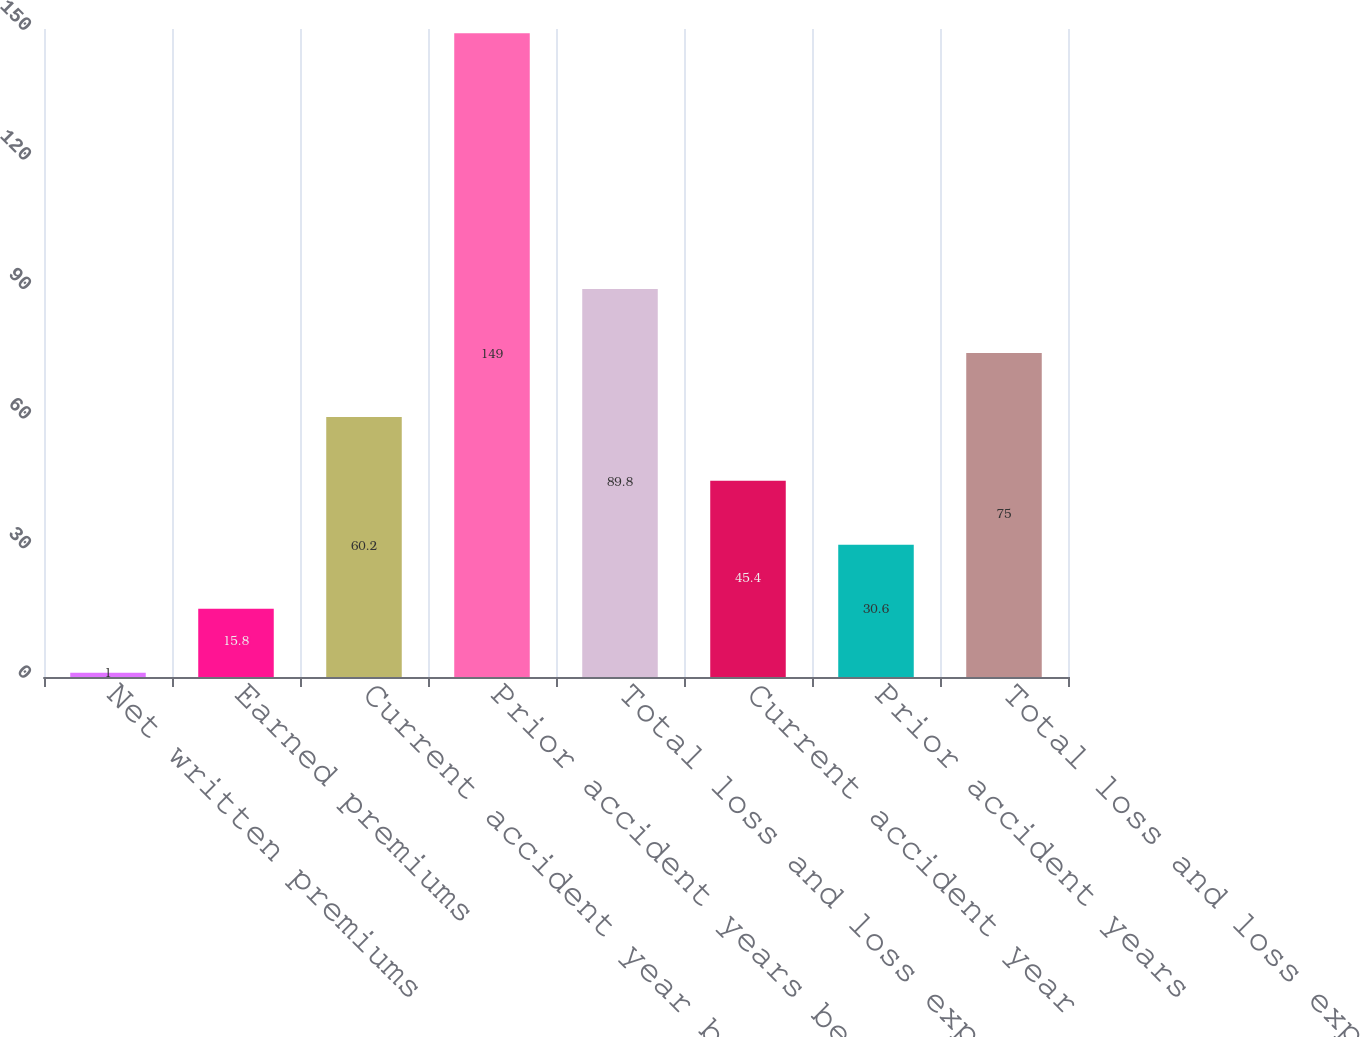Convert chart. <chart><loc_0><loc_0><loc_500><loc_500><bar_chart><fcel>Net written premiums<fcel>Earned premiums<fcel>Current accident year before<fcel>Prior accident years before<fcel>Total loss and loss expenses<fcel>Current accident year<fcel>Prior accident years<fcel>Total loss and loss expense<nl><fcel>1<fcel>15.8<fcel>60.2<fcel>149<fcel>89.8<fcel>45.4<fcel>30.6<fcel>75<nl></chart> 